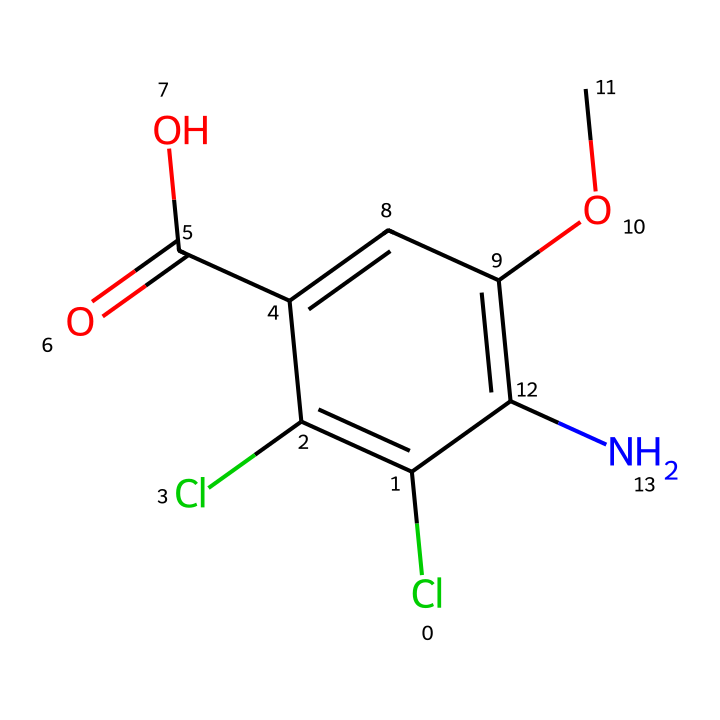What is the molecular formula of dicamba? The SMILES representation can be decoded to determine the elements present and their quantities. The structure contains 8 carbon atoms (C), 8 hydrogen atoms (H), 2 chlorine atoms (Cl), 1 nitrogen atom (N), and 2 oxygen atoms (O). Therefore, the molecular formula is C8H8Cl2N2O2.
Answer: C8H8Cl2N2O2 How many chlorine atoms are present in dicamba? By analyzing the SMILES representation, we can see there are two 'Cl' present in the structure. This directly indicates the number of chlorine atoms in the molecule.
Answer: 2 What functional group is indicated by "C(=O)O" in the structure? The 'C(=O)O' portion of the SMILES represents a carboxylic acid functional group due to the presence of a carbonyl (C=O) and a hydroxyl (O-H) group attached to the same carbon atom. This identifies it as a carboxylic acid.
Answer: carboxylic acid Does dicamba have any aromatic characteristics? The presence of the 'c' in the SMILES signifies that there are aromatic (cyclic and conjugated) carbon atoms in the structure. The specific arrangement of the carbon atoms contributes to aromatic properties, confirming that dicamba is an aromatic compound.
Answer: yes What type of herbicide is dicamba classified as? Dicamba is classified as a systemic herbicide, which means it is absorbed and translocated through the plant system to control weeds effectively. The molecular structure indicates its ability to disrupt plant growth processes.
Answer: systemic How could the chlorine atoms affect the properties of dicamba? Chlorine atoms can enhance the herbicidal activity of compounds like dicamba by increasing lipophilicity, which aids in absorption through plant membranes, enhancing its effectiveness as an herbicide. Additionally, they may influence the herbicide's environmental stability and volatility.
Answer: increase effectiveness 